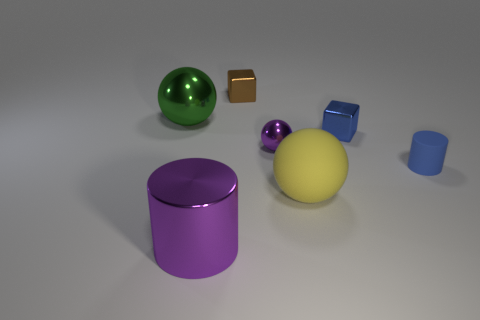Are there fewer small brown cubes that are in front of the tiny matte cylinder than big cylinders?
Provide a succinct answer. Yes. Is there anything else that is the same shape as the small purple shiny thing?
Your answer should be compact. Yes. Are any tiny blue metallic cubes visible?
Make the answer very short. Yes. Is the number of tiny red things less than the number of rubber spheres?
Keep it short and to the point. Yes. How many small yellow cylinders have the same material as the big purple cylinder?
Offer a very short reply. 0. There is a cylinder that is the same material as the green object; what is its color?
Make the answer very short. Purple. What is the shape of the big green thing?
Your response must be concise. Sphere. How many tiny things have the same color as the big metal cylinder?
Ensure brevity in your answer.  1. There is a purple metallic object that is the same size as the blue metal cube; what is its shape?
Provide a short and direct response. Sphere. Are there any metal blocks that have the same size as the brown metallic object?
Make the answer very short. Yes. 